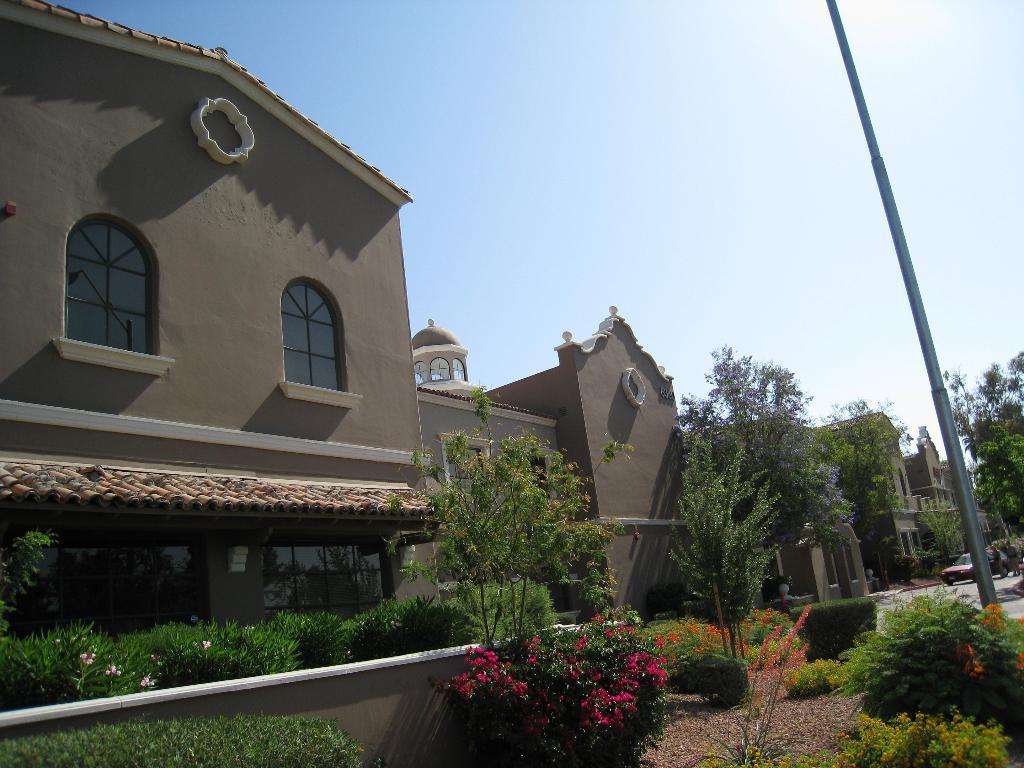Please provide a concise description of this image. In this image there are buildings, in front of the buildings there are trees, plants and there is a pole. In the background there is a sky. 